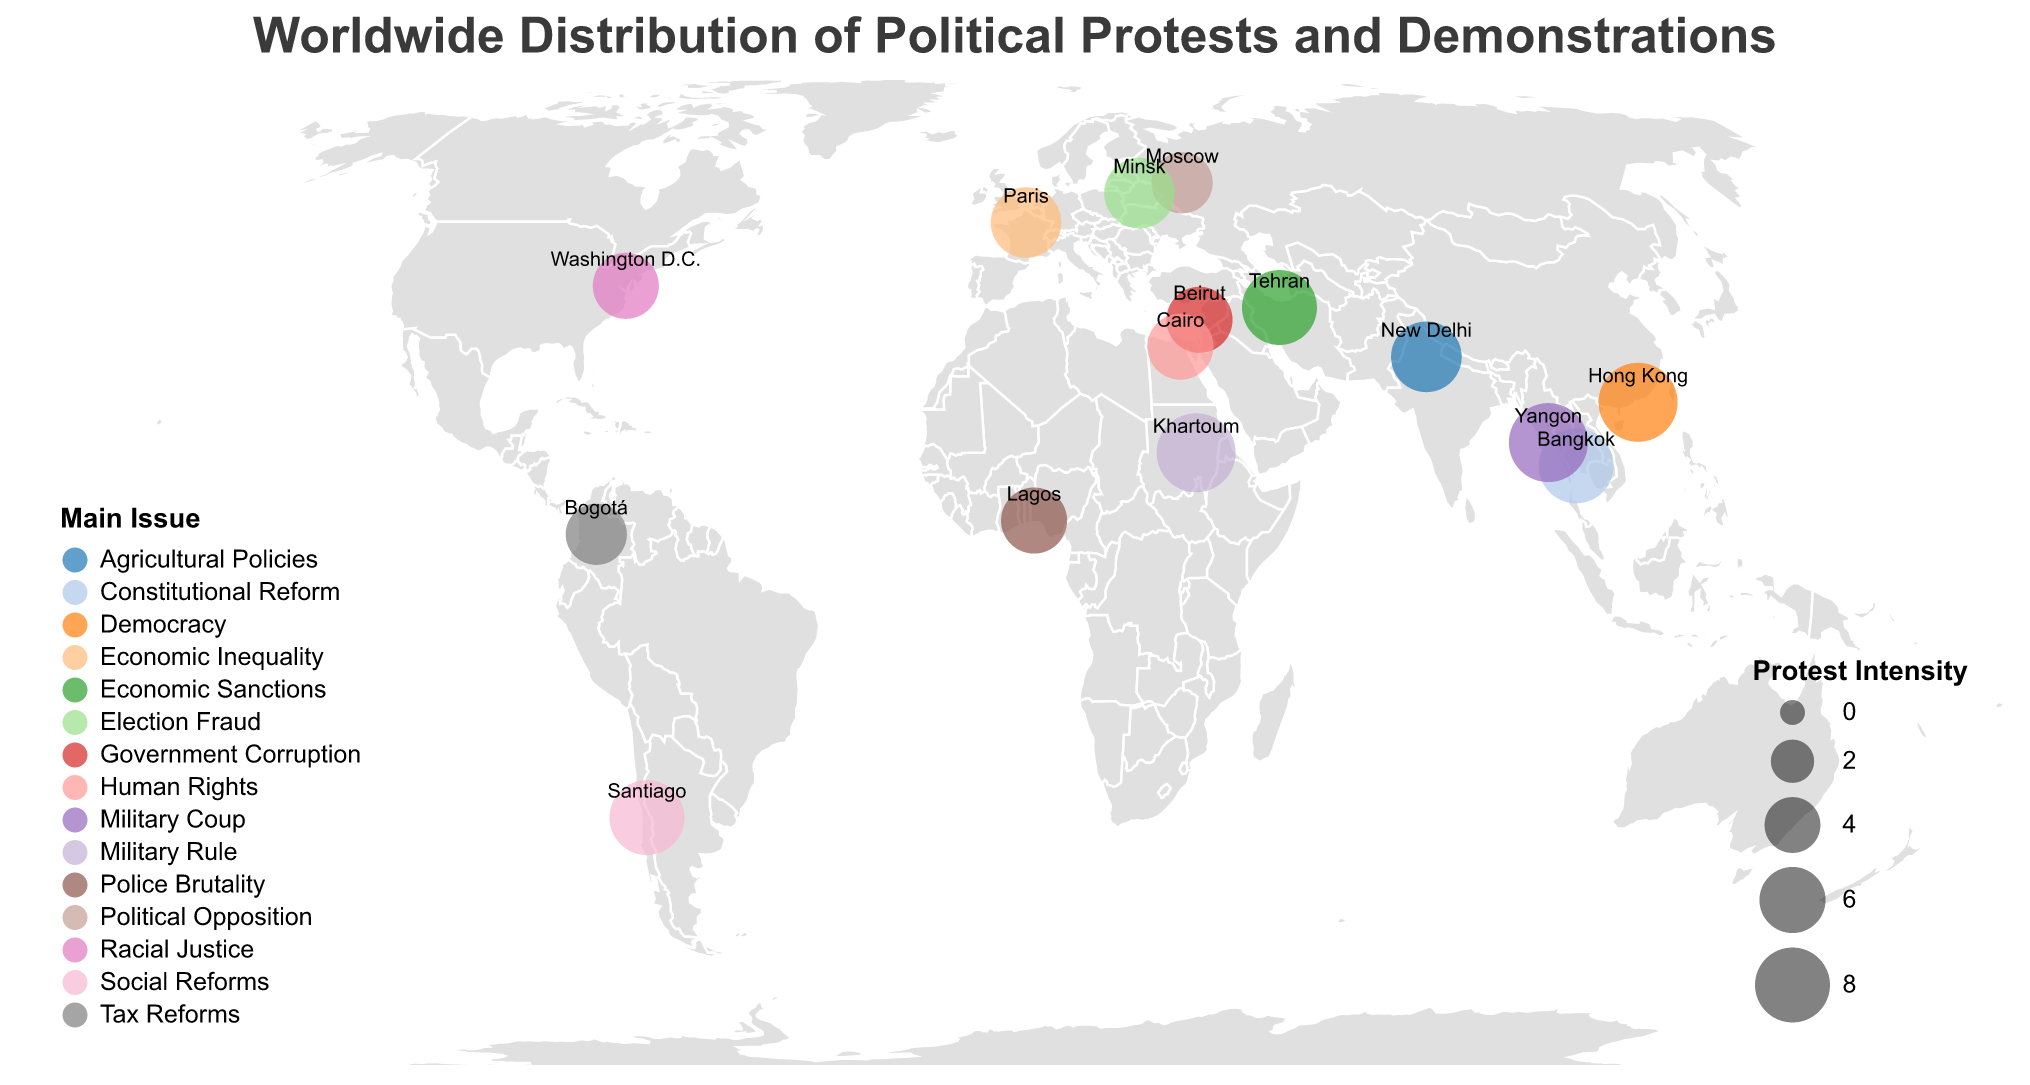What is the title of the figure? The title of the figure can be found at the top center of the plot, written in bold and larger font size, indicating the overall theme of the visual representation.
Answer: Worldwide Distribution of Political Protests and Demonstrations How many regions have a protest intensity level of 9? By examining the size of the circles and reading the legend, we can identify the regions that correspond to the highest value in the "Protest Intensity" scale.
Answer: 4 Which regions have the main issue of 'Military Rule'? The main issue associated with protests can be identified by the color of the circles. Matching the color to the legend reveals the specific regions.
Answer: Khartoum What is the latitude and longitude of Bangkok? The latitude and longitude of each region are labeled as coordinates on the plot. Find Bangkok and read its coordinates.
Answer: 13.7563, 100.5018 Which region has the lowest protest intensity? By comparing the size of all circles, we can identify the circle with the smallest size, which represents the lowest protest intensity.
Answer: Moscow Compare the protest intensity between Santiago and New Delhi. Which one has a higher intensity? Locate Santiago and New Delhi on the map and compare the sizes of the respective circles to determine which is larger.
Answer: Santiago What is the average protest intensity of regions with the main issue of 'Economic Inequality'? Identify regions with the color corresponding to 'Economic Inequality' in the legend, sum their protest intensities, and divide by the number of such regions. (Only one region, Paris, with intensity 7)
Answer: 7 Which two regions are located in the highest and lowest latitude? Locate the circles with the highest and lowest latitude by examining the vertical positioning on the map.
Answer: Moscow (highest), Santiago (lowest) Among the regions listed, which one is experiencing protests due to 'Government Corruption'? Use the legend to find the color associated with 'Government Corruption' and locate the region with that color-coded circle.
Answer: Beirut 